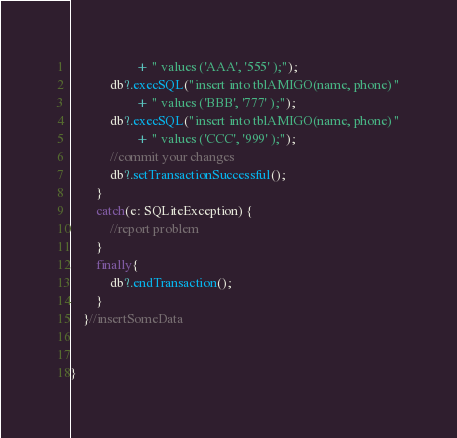<code> <loc_0><loc_0><loc_500><loc_500><_Kotlin_>                    + " values ('AAA', '555' );");
            db?.execSQL("insert into tblAMIGO(name, phone) "
                    + " values ('BBB', '777' );");
            db?.execSQL("insert into tblAMIGO(name, phone) "
                    + " values ('CCC', '999' );");
            //commit your changes
            db?.setTransactionSuccessful();
        }
        catch(e: SQLiteException) {
            //report problem
        }
        finally{
            db?.endTransaction();
        }
    }//insertSomeData


}</code> 